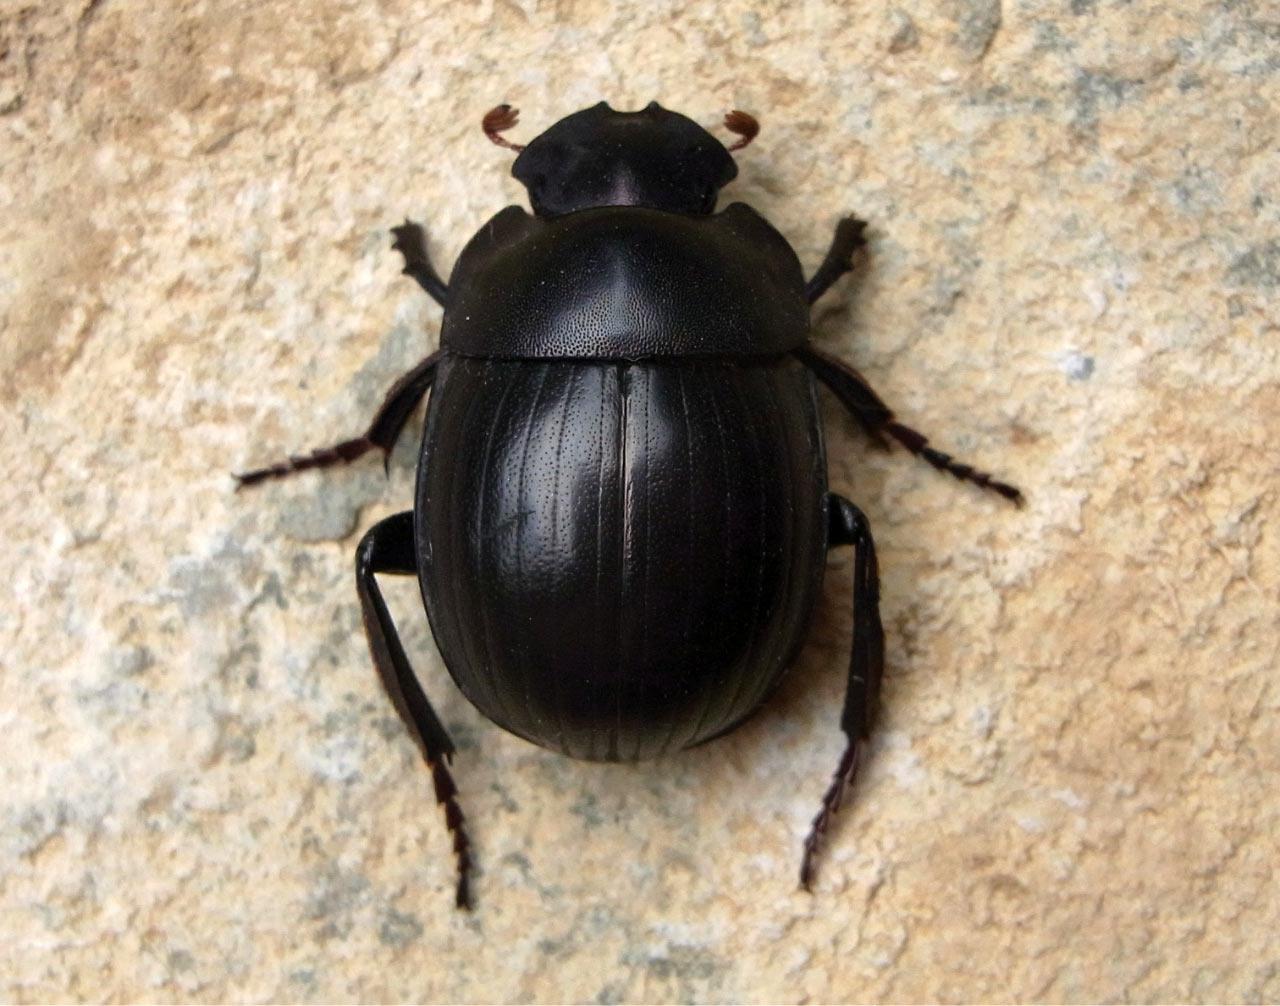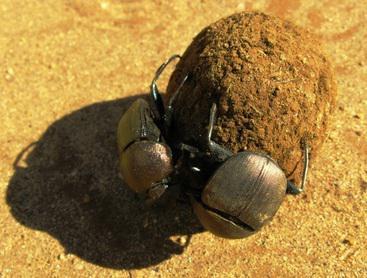The first image is the image on the left, the second image is the image on the right. For the images displayed, is the sentence "There is no dung in one image." factually correct? Answer yes or no. Yes. The first image is the image on the left, the second image is the image on the right. Analyze the images presented: Is the assertion "Each image shows exactly one dark beetle in contact with one brown ball." valid? Answer yes or no. No. 